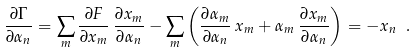Convert formula to latex. <formula><loc_0><loc_0><loc_500><loc_500>\frac { \partial \Gamma } { \partial \alpha _ { n } } = \sum _ { m } \frac { \partial F } { \partial x _ { m } } \, \frac { \partial x _ { m } } { \partial \alpha _ { n } } - \sum _ { m } \left ( \frac { \partial \alpha _ { m } } { \partial \alpha _ { n } } \, x _ { m } + \alpha _ { m } \, \frac { \partial x _ { m } } { \partial \alpha _ { n } } \right ) = - x _ { n } \ .</formula> 